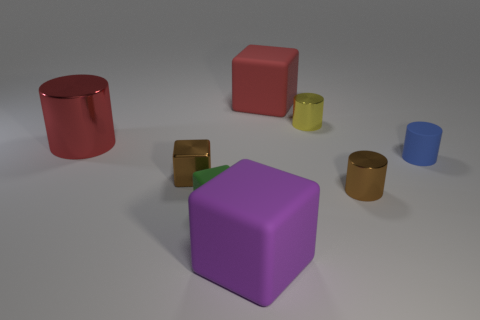Subtract all tiny yellow metallic cylinders. How many cylinders are left? 3 Add 1 tiny gray rubber things. How many objects exist? 9 Subtract all purple blocks. How many blocks are left? 3 Subtract all purple cylinders. Subtract all blue blocks. How many cylinders are left? 4 Subtract all green cylinders. How many yellow cubes are left? 0 Subtract all big purple blocks. Subtract all red cylinders. How many objects are left? 6 Add 2 rubber cylinders. How many rubber cylinders are left? 3 Add 6 blue things. How many blue things exist? 7 Subtract 0 red spheres. How many objects are left? 8 Subtract 2 blocks. How many blocks are left? 2 